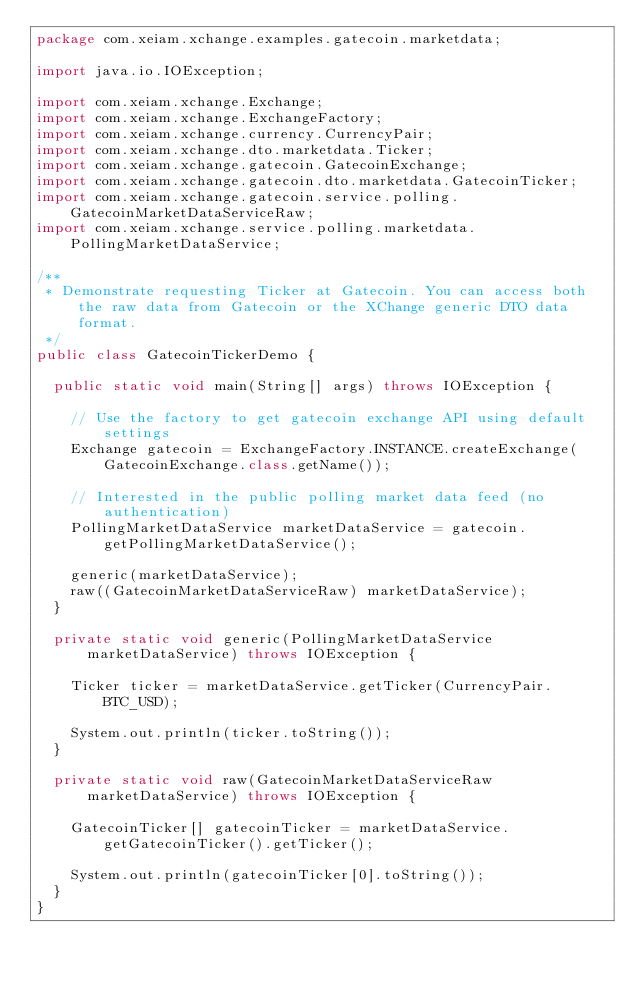<code> <loc_0><loc_0><loc_500><loc_500><_Java_>package com.xeiam.xchange.examples.gatecoin.marketdata;

import java.io.IOException;

import com.xeiam.xchange.Exchange;
import com.xeiam.xchange.ExchangeFactory;
import com.xeiam.xchange.currency.CurrencyPair;
import com.xeiam.xchange.dto.marketdata.Ticker;
import com.xeiam.xchange.gatecoin.GatecoinExchange;
import com.xeiam.xchange.gatecoin.dto.marketdata.GatecoinTicker;
import com.xeiam.xchange.gatecoin.service.polling.GatecoinMarketDataServiceRaw;
import com.xeiam.xchange.service.polling.marketdata.PollingMarketDataService;

/**
 * Demonstrate requesting Ticker at Gatecoin. You can access both the raw data from Gatecoin or the XChange generic DTO data format.
 */
public class GatecoinTickerDemo {

  public static void main(String[] args) throws IOException {

    // Use the factory to get gatecoin exchange API using default settings
    Exchange gatecoin = ExchangeFactory.INSTANCE.createExchange(GatecoinExchange.class.getName());

    // Interested in the public polling market data feed (no authentication)
    PollingMarketDataService marketDataService = gatecoin.getPollingMarketDataService();

    generic(marketDataService);
    raw((GatecoinMarketDataServiceRaw) marketDataService);
  }

  private static void generic(PollingMarketDataService marketDataService) throws IOException {

    Ticker ticker = marketDataService.getTicker(CurrencyPair.BTC_USD);

    System.out.println(ticker.toString());
  }

  private static void raw(GatecoinMarketDataServiceRaw marketDataService) throws IOException {

    GatecoinTicker[] gatecoinTicker = marketDataService.getGatecoinTicker().getTicker();

    System.out.println(gatecoinTicker[0].toString());
  }
}
</code> 